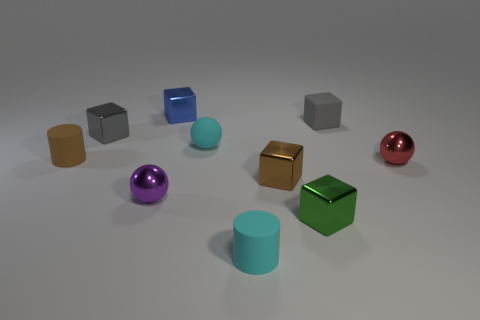Subtract all blue blocks. How many blocks are left? 4 Subtract all tiny green cubes. How many cubes are left? 4 Subtract all brown balls. Subtract all green blocks. How many balls are left? 3 Subtract all cylinders. How many objects are left? 8 Add 1 gray metal cylinders. How many gray metal cylinders exist? 1 Subtract 1 red spheres. How many objects are left? 9 Subtract all small brown matte spheres. Subtract all red spheres. How many objects are left? 9 Add 2 tiny brown cylinders. How many tiny brown cylinders are left? 3 